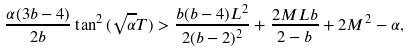<formula> <loc_0><loc_0><loc_500><loc_500>\frac { \alpha ( 3 b - 4 ) } { 2 b } \tan ^ { 2 } { ( \sqrt { \alpha } T ) } > \frac { b ( b - 4 ) L ^ { 2 } } { 2 ( b - 2 ) ^ { 2 } } + \frac { 2 M L b } { 2 - b } + 2 M ^ { 2 } - \alpha ,</formula> 